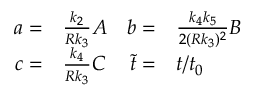Convert formula to latex. <formula><loc_0><loc_0><loc_500><loc_500>\begin{array} { r l r l } { a = } & \frac { k _ { 2 } } { R k _ { 3 } } A } & { b = } & \frac { k _ { 4 } k _ { 5 } } { 2 ( R k _ { 3 } ) ^ { 2 } } B } \\ { c = } & \frac { k _ { 4 } } { R k _ { 3 } } C } & { \tilde { t } = } & t / t _ { 0 } } \end{array}</formula> 